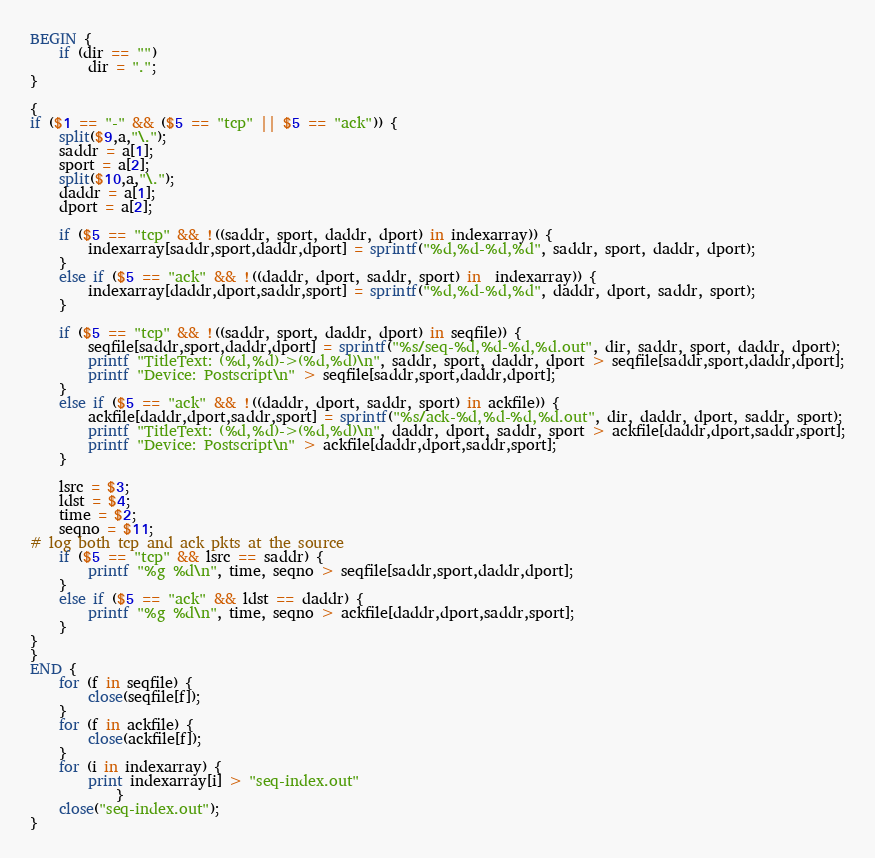<code> <loc_0><loc_0><loc_500><loc_500><_Awk_>BEGIN {
	if (dir == "")
		dir = ".";
}	

{
if ($1 == "-" && ($5 == "tcp" || $5 == "ack")) {
	split($9,a,"\.");
	saddr = a[1];
	sport = a[2];
	split($10,a,"\.");
	daddr = a[1];
	dport = a[2];
	
	if ($5 == "tcp" && !((saddr, sport, daddr, dport) in indexarray)) {
		indexarray[saddr,sport,daddr,dport] = sprintf("%d,%d-%d,%d", saddr, sport, daddr, dport);
	}
	else if ($5 == "ack" && !((daddr, dport, saddr, sport) in  indexarray)) {
		indexarray[daddr,dport,saddr,sport] = sprintf("%d,%d-%d,%d", daddr, dport, saddr, sport);
	}
	
	if ($5 == "tcp" && !((saddr, sport, daddr, dport) in seqfile)) {
		seqfile[saddr,sport,daddr,dport] = sprintf("%s/seq-%d,%d-%d,%d.out", dir, saddr, sport, daddr, dport);
		printf "TitleText: (%d,%d)->(%d,%d)\n", saddr, sport, daddr, dport > seqfile[saddr,sport,daddr,dport];
		printf "Device: Postscript\n" > seqfile[saddr,sport,daddr,dport];
	}
	else if ($5 == "ack" && !((daddr, dport, saddr, sport) in ackfile)) {
		ackfile[daddr,dport,saddr,sport] = sprintf("%s/ack-%d,%d-%d,%d.out", dir, daddr, dport, saddr, sport);
		printf "TitleText: (%d,%d)->(%d,%d)\n", daddr, dport, saddr, sport > ackfile[daddr,dport,saddr,sport];
		printf "Device: Postscript\n" > ackfile[daddr,dport,saddr,sport];
	}
	
	lsrc = $3;
	ldst = $4;
	time = $2;
	seqno = $11;
# log both tcp and ack pkts at the source
	if ($5 == "tcp" && lsrc == saddr) {
		printf "%g %d\n", time, seqno > seqfile[saddr,sport,daddr,dport];
	}
	else if ($5 == "ack" && ldst == daddr) {
		printf "%g %d\n", time, seqno > ackfile[daddr,dport,saddr,sport];
	} 
}
}
END {
	for (f in seqfile) {
		close(seqfile[f]);
	}
	for (f in ackfile) {
		close(ackfile[f]);
	}
	for (i in indexarray) {
		print indexarray[i] > "seq-index.out"
			}
	close("seq-index.out");
}


</code> 